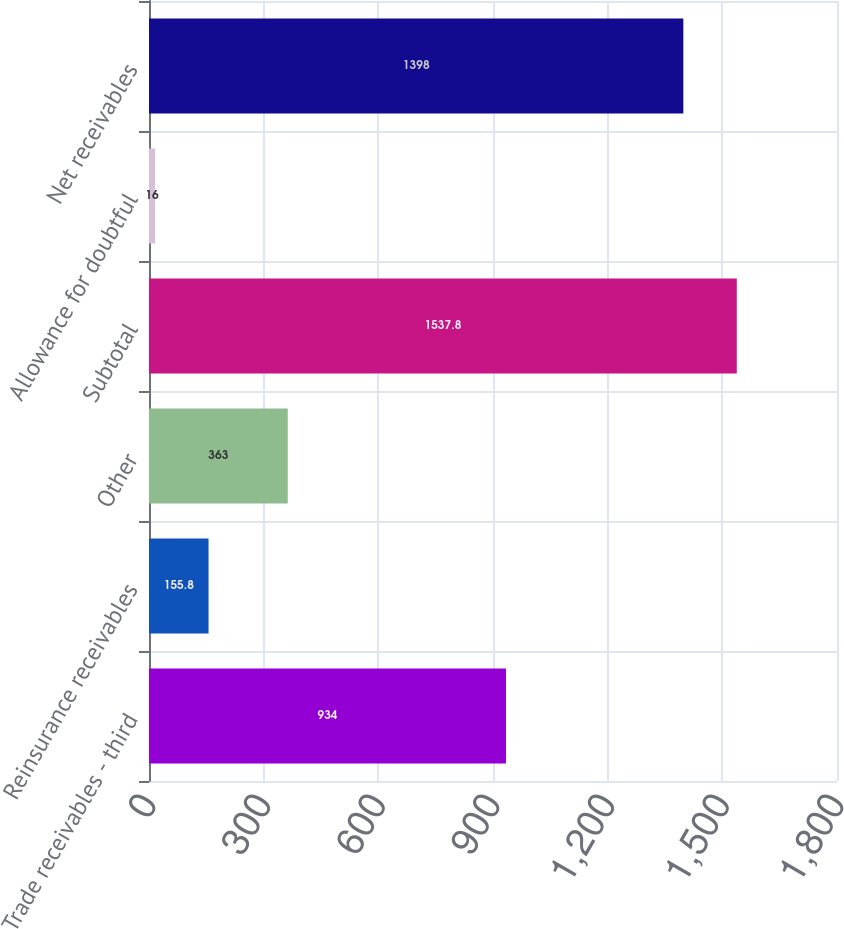Convert chart to OTSL. <chart><loc_0><loc_0><loc_500><loc_500><bar_chart><fcel>Trade receivables - third<fcel>Reinsurance receivables<fcel>Other<fcel>Subtotal<fcel>Allowance for doubtful<fcel>Net receivables<nl><fcel>934<fcel>155.8<fcel>363<fcel>1537.8<fcel>16<fcel>1398<nl></chart> 